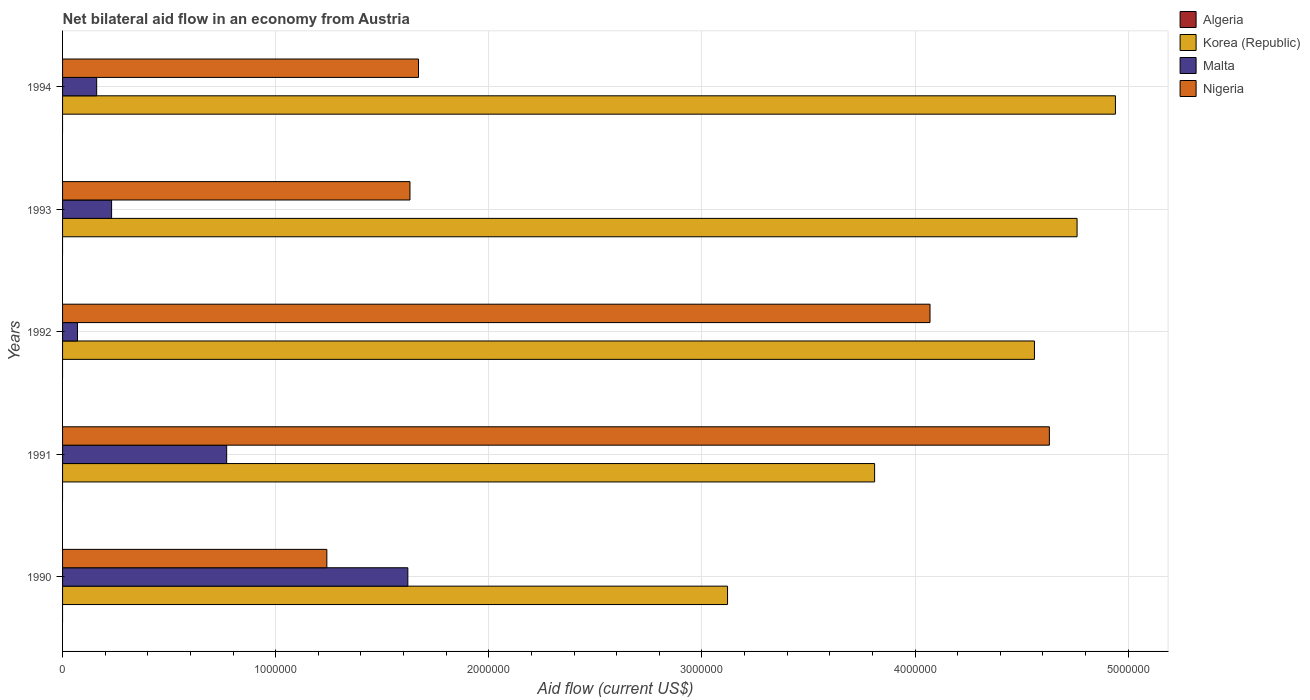Are the number of bars per tick equal to the number of legend labels?
Your answer should be compact. No. Are the number of bars on each tick of the Y-axis equal?
Provide a short and direct response. Yes. How many bars are there on the 5th tick from the bottom?
Make the answer very short. 3. What is the net bilateral aid flow in Korea (Republic) in 1994?
Provide a short and direct response. 4.94e+06. Across all years, what is the maximum net bilateral aid flow in Nigeria?
Offer a terse response. 4.63e+06. Across all years, what is the minimum net bilateral aid flow in Algeria?
Offer a terse response. 0. In which year was the net bilateral aid flow in Korea (Republic) maximum?
Your answer should be compact. 1994. What is the total net bilateral aid flow in Nigeria in the graph?
Make the answer very short. 1.32e+07. What is the difference between the net bilateral aid flow in Nigeria in 1990 and that in 1992?
Provide a short and direct response. -2.83e+06. What is the difference between the net bilateral aid flow in Nigeria in 1994 and the net bilateral aid flow in Malta in 1992?
Your answer should be very brief. 1.60e+06. What is the average net bilateral aid flow in Nigeria per year?
Your answer should be very brief. 2.65e+06. In the year 1993, what is the difference between the net bilateral aid flow in Nigeria and net bilateral aid flow in Malta?
Offer a terse response. 1.40e+06. In how many years, is the net bilateral aid flow in Nigeria greater than 3600000 US$?
Provide a short and direct response. 2. What is the ratio of the net bilateral aid flow in Malta in 1992 to that in 1993?
Offer a very short reply. 0.3. Is the net bilateral aid flow in Korea (Republic) in 1990 less than that in 1992?
Ensure brevity in your answer.  Yes. Is the difference between the net bilateral aid flow in Nigeria in 1990 and 1993 greater than the difference between the net bilateral aid flow in Malta in 1990 and 1993?
Offer a terse response. No. What is the difference between the highest and the lowest net bilateral aid flow in Malta?
Keep it short and to the point. 1.55e+06. In how many years, is the net bilateral aid flow in Korea (Republic) greater than the average net bilateral aid flow in Korea (Republic) taken over all years?
Offer a very short reply. 3. Is the sum of the net bilateral aid flow in Malta in 1992 and 1993 greater than the maximum net bilateral aid flow in Korea (Republic) across all years?
Your response must be concise. No. Is it the case that in every year, the sum of the net bilateral aid flow in Malta and net bilateral aid flow in Nigeria is greater than the net bilateral aid flow in Korea (Republic)?
Keep it short and to the point. No. How many bars are there?
Provide a succinct answer. 15. Are all the bars in the graph horizontal?
Provide a succinct answer. Yes. How many legend labels are there?
Provide a short and direct response. 4. What is the title of the graph?
Provide a short and direct response. Net bilateral aid flow in an economy from Austria. What is the label or title of the Y-axis?
Provide a succinct answer. Years. What is the Aid flow (current US$) in Korea (Republic) in 1990?
Keep it short and to the point. 3.12e+06. What is the Aid flow (current US$) in Malta in 1990?
Make the answer very short. 1.62e+06. What is the Aid flow (current US$) of Nigeria in 1990?
Offer a very short reply. 1.24e+06. What is the Aid flow (current US$) of Korea (Republic) in 1991?
Ensure brevity in your answer.  3.81e+06. What is the Aid flow (current US$) of Malta in 1991?
Make the answer very short. 7.70e+05. What is the Aid flow (current US$) in Nigeria in 1991?
Provide a short and direct response. 4.63e+06. What is the Aid flow (current US$) of Korea (Republic) in 1992?
Your response must be concise. 4.56e+06. What is the Aid flow (current US$) in Malta in 1992?
Ensure brevity in your answer.  7.00e+04. What is the Aid flow (current US$) in Nigeria in 1992?
Your response must be concise. 4.07e+06. What is the Aid flow (current US$) in Algeria in 1993?
Your response must be concise. 0. What is the Aid flow (current US$) in Korea (Republic) in 1993?
Give a very brief answer. 4.76e+06. What is the Aid flow (current US$) in Malta in 1993?
Provide a succinct answer. 2.30e+05. What is the Aid flow (current US$) in Nigeria in 1993?
Your answer should be very brief. 1.63e+06. What is the Aid flow (current US$) in Algeria in 1994?
Ensure brevity in your answer.  0. What is the Aid flow (current US$) of Korea (Republic) in 1994?
Provide a succinct answer. 4.94e+06. What is the Aid flow (current US$) in Malta in 1994?
Provide a short and direct response. 1.60e+05. What is the Aid flow (current US$) in Nigeria in 1994?
Ensure brevity in your answer.  1.67e+06. Across all years, what is the maximum Aid flow (current US$) in Korea (Republic)?
Make the answer very short. 4.94e+06. Across all years, what is the maximum Aid flow (current US$) in Malta?
Ensure brevity in your answer.  1.62e+06. Across all years, what is the maximum Aid flow (current US$) in Nigeria?
Make the answer very short. 4.63e+06. Across all years, what is the minimum Aid flow (current US$) in Korea (Republic)?
Your answer should be very brief. 3.12e+06. Across all years, what is the minimum Aid flow (current US$) in Malta?
Keep it short and to the point. 7.00e+04. Across all years, what is the minimum Aid flow (current US$) of Nigeria?
Keep it short and to the point. 1.24e+06. What is the total Aid flow (current US$) in Korea (Republic) in the graph?
Keep it short and to the point. 2.12e+07. What is the total Aid flow (current US$) of Malta in the graph?
Ensure brevity in your answer.  2.85e+06. What is the total Aid flow (current US$) in Nigeria in the graph?
Provide a short and direct response. 1.32e+07. What is the difference between the Aid flow (current US$) of Korea (Republic) in 1990 and that in 1991?
Offer a terse response. -6.90e+05. What is the difference between the Aid flow (current US$) of Malta in 1990 and that in 1991?
Offer a terse response. 8.50e+05. What is the difference between the Aid flow (current US$) in Nigeria in 1990 and that in 1991?
Your answer should be compact. -3.39e+06. What is the difference between the Aid flow (current US$) in Korea (Republic) in 1990 and that in 1992?
Give a very brief answer. -1.44e+06. What is the difference between the Aid flow (current US$) in Malta in 1990 and that in 1992?
Give a very brief answer. 1.55e+06. What is the difference between the Aid flow (current US$) of Nigeria in 1990 and that in 1992?
Give a very brief answer. -2.83e+06. What is the difference between the Aid flow (current US$) in Korea (Republic) in 1990 and that in 1993?
Ensure brevity in your answer.  -1.64e+06. What is the difference between the Aid flow (current US$) in Malta in 1990 and that in 1993?
Your answer should be very brief. 1.39e+06. What is the difference between the Aid flow (current US$) of Nigeria in 1990 and that in 1993?
Provide a succinct answer. -3.90e+05. What is the difference between the Aid flow (current US$) in Korea (Republic) in 1990 and that in 1994?
Offer a very short reply. -1.82e+06. What is the difference between the Aid flow (current US$) of Malta in 1990 and that in 1994?
Ensure brevity in your answer.  1.46e+06. What is the difference between the Aid flow (current US$) in Nigeria in 1990 and that in 1994?
Your answer should be very brief. -4.30e+05. What is the difference between the Aid flow (current US$) of Korea (Republic) in 1991 and that in 1992?
Offer a terse response. -7.50e+05. What is the difference between the Aid flow (current US$) in Malta in 1991 and that in 1992?
Ensure brevity in your answer.  7.00e+05. What is the difference between the Aid flow (current US$) in Nigeria in 1991 and that in 1992?
Keep it short and to the point. 5.60e+05. What is the difference between the Aid flow (current US$) of Korea (Republic) in 1991 and that in 1993?
Offer a very short reply. -9.50e+05. What is the difference between the Aid flow (current US$) in Malta in 1991 and that in 1993?
Provide a succinct answer. 5.40e+05. What is the difference between the Aid flow (current US$) of Nigeria in 1991 and that in 1993?
Ensure brevity in your answer.  3.00e+06. What is the difference between the Aid flow (current US$) of Korea (Republic) in 1991 and that in 1994?
Your answer should be compact. -1.13e+06. What is the difference between the Aid flow (current US$) in Malta in 1991 and that in 1994?
Provide a short and direct response. 6.10e+05. What is the difference between the Aid flow (current US$) in Nigeria in 1991 and that in 1994?
Your answer should be very brief. 2.96e+06. What is the difference between the Aid flow (current US$) in Nigeria in 1992 and that in 1993?
Provide a succinct answer. 2.44e+06. What is the difference between the Aid flow (current US$) in Korea (Republic) in 1992 and that in 1994?
Ensure brevity in your answer.  -3.80e+05. What is the difference between the Aid flow (current US$) of Nigeria in 1992 and that in 1994?
Your response must be concise. 2.40e+06. What is the difference between the Aid flow (current US$) in Malta in 1993 and that in 1994?
Keep it short and to the point. 7.00e+04. What is the difference between the Aid flow (current US$) of Nigeria in 1993 and that in 1994?
Provide a succinct answer. -4.00e+04. What is the difference between the Aid flow (current US$) in Korea (Republic) in 1990 and the Aid flow (current US$) in Malta in 1991?
Provide a succinct answer. 2.35e+06. What is the difference between the Aid flow (current US$) of Korea (Republic) in 1990 and the Aid flow (current US$) of Nigeria in 1991?
Keep it short and to the point. -1.51e+06. What is the difference between the Aid flow (current US$) in Malta in 1990 and the Aid flow (current US$) in Nigeria in 1991?
Ensure brevity in your answer.  -3.01e+06. What is the difference between the Aid flow (current US$) of Korea (Republic) in 1990 and the Aid flow (current US$) of Malta in 1992?
Give a very brief answer. 3.05e+06. What is the difference between the Aid flow (current US$) of Korea (Republic) in 1990 and the Aid flow (current US$) of Nigeria in 1992?
Provide a short and direct response. -9.50e+05. What is the difference between the Aid flow (current US$) of Malta in 1990 and the Aid flow (current US$) of Nigeria in 1992?
Provide a succinct answer. -2.45e+06. What is the difference between the Aid flow (current US$) of Korea (Republic) in 1990 and the Aid flow (current US$) of Malta in 1993?
Keep it short and to the point. 2.89e+06. What is the difference between the Aid flow (current US$) in Korea (Republic) in 1990 and the Aid flow (current US$) in Nigeria in 1993?
Your response must be concise. 1.49e+06. What is the difference between the Aid flow (current US$) of Malta in 1990 and the Aid flow (current US$) of Nigeria in 1993?
Offer a terse response. -10000. What is the difference between the Aid flow (current US$) of Korea (Republic) in 1990 and the Aid flow (current US$) of Malta in 1994?
Give a very brief answer. 2.96e+06. What is the difference between the Aid flow (current US$) of Korea (Republic) in 1990 and the Aid flow (current US$) of Nigeria in 1994?
Your response must be concise. 1.45e+06. What is the difference between the Aid flow (current US$) in Korea (Republic) in 1991 and the Aid flow (current US$) in Malta in 1992?
Make the answer very short. 3.74e+06. What is the difference between the Aid flow (current US$) of Malta in 1991 and the Aid flow (current US$) of Nigeria in 1992?
Your answer should be compact. -3.30e+06. What is the difference between the Aid flow (current US$) of Korea (Republic) in 1991 and the Aid flow (current US$) of Malta in 1993?
Provide a short and direct response. 3.58e+06. What is the difference between the Aid flow (current US$) of Korea (Republic) in 1991 and the Aid flow (current US$) of Nigeria in 1993?
Your response must be concise. 2.18e+06. What is the difference between the Aid flow (current US$) of Malta in 1991 and the Aid flow (current US$) of Nigeria in 1993?
Your answer should be compact. -8.60e+05. What is the difference between the Aid flow (current US$) in Korea (Republic) in 1991 and the Aid flow (current US$) in Malta in 1994?
Your answer should be very brief. 3.65e+06. What is the difference between the Aid flow (current US$) of Korea (Republic) in 1991 and the Aid flow (current US$) of Nigeria in 1994?
Give a very brief answer. 2.14e+06. What is the difference between the Aid flow (current US$) in Malta in 1991 and the Aid flow (current US$) in Nigeria in 1994?
Offer a terse response. -9.00e+05. What is the difference between the Aid flow (current US$) in Korea (Republic) in 1992 and the Aid flow (current US$) in Malta in 1993?
Keep it short and to the point. 4.33e+06. What is the difference between the Aid flow (current US$) in Korea (Republic) in 1992 and the Aid flow (current US$) in Nigeria in 1993?
Offer a very short reply. 2.93e+06. What is the difference between the Aid flow (current US$) in Malta in 1992 and the Aid flow (current US$) in Nigeria in 1993?
Keep it short and to the point. -1.56e+06. What is the difference between the Aid flow (current US$) of Korea (Republic) in 1992 and the Aid flow (current US$) of Malta in 1994?
Give a very brief answer. 4.40e+06. What is the difference between the Aid flow (current US$) in Korea (Republic) in 1992 and the Aid flow (current US$) in Nigeria in 1994?
Ensure brevity in your answer.  2.89e+06. What is the difference between the Aid flow (current US$) in Malta in 1992 and the Aid flow (current US$) in Nigeria in 1994?
Ensure brevity in your answer.  -1.60e+06. What is the difference between the Aid flow (current US$) of Korea (Republic) in 1993 and the Aid flow (current US$) of Malta in 1994?
Give a very brief answer. 4.60e+06. What is the difference between the Aid flow (current US$) of Korea (Republic) in 1993 and the Aid flow (current US$) of Nigeria in 1994?
Offer a very short reply. 3.09e+06. What is the difference between the Aid flow (current US$) in Malta in 1993 and the Aid flow (current US$) in Nigeria in 1994?
Offer a terse response. -1.44e+06. What is the average Aid flow (current US$) in Algeria per year?
Keep it short and to the point. 0. What is the average Aid flow (current US$) in Korea (Republic) per year?
Your answer should be very brief. 4.24e+06. What is the average Aid flow (current US$) in Malta per year?
Provide a short and direct response. 5.70e+05. What is the average Aid flow (current US$) in Nigeria per year?
Offer a very short reply. 2.65e+06. In the year 1990, what is the difference between the Aid flow (current US$) of Korea (Republic) and Aid flow (current US$) of Malta?
Offer a very short reply. 1.50e+06. In the year 1990, what is the difference between the Aid flow (current US$) in Korea (Republic) and Aid flow (current US$) in Nigeria?
Offer a very short reply. 1.88e+06. In the year 1991, what is the difference between the Aid flow (current US$) of Korea (Republic) and Aid flow (current US$) of Malta?
Ensure brevity in your answer.  3.04e+06. In the year 1991, what is the difference between the Aid flow (current US$) in Korea (Republic) and Aid flow (current US$) in Nigeria?
Your answer should be very brief. -8.20e+05. In the year 1991, what is the difference between the Aid flow (current US$) in Malta and Aid flow (current US$) in Nigeria?
Offer a terse response. -3.86e+06. In the year 1992, what is the difference between the Aid flow (current US$) in Korea (Republic) and Aid flow (current US$) in Malta?
Give a very brief answer. 4.49e+06. In the year 1992, what is the difference between the Aid flow (current US$) of Korea (Republic) and Aid flow (current US$) of Nigeria?
Offer a terse response. 4.90e+05. In the year 1993, what is the difference between the Aid flow (current US$) in Korea (Republic) and Aid flow (current US$) in Malta?
Give a very brief answer. 4.53e+06. In the year 1993, what is the difference between the Aid flow (current US$) in Korea (Republic) and Aid flow (current US$) in Nigeria?
Your response must be concise. 3.13e+06. In the year 1993, what is the difference between the Aid flow (current US$) in Malta and Aid flow (current US$) in Nigeria?
Your answer should be very brief. -1.40e+06. In the year 1994, what is the difference between the Aid flow (current US$) of Korea (Republic) and Aid flow (current US$) of Malta?
Offer a very short reply. 4.78e+06. In the year 1994, what is the difference between the Aid flow (current US$) of Korea (Republic) and Aid flow (current US$) of Nigeria?
Give a very brief answer. 3.27e+06. In the year 1994, what is the difference between the Aid flow (current US$) in Malta and Aid flow (current US$) in Nigeria?
Offer a very short reply. -1.51e+06. What is the ratio of the Aid flow (current US$) in Korea (Republic) in 1990 to that in 1991?
Provide a succinct answer. 0.82. What is the ratio of the Aid flow (current US$) in Malta in 1990 to that in 1991?
Provide a succinct answer. 2.1. What is the ratio of the Aid flow (current US$) of Nigeria in 1990 to that in 1991?
Your answer should be compact. 0.27. What is the ratio of the Aid flow (current US$) in Korea (Republic) in 1990 to that in 1992?
Your answer should be compact. 0.68. What is the ratio of the Aid flow (current US$) of Malta in 1990 to that in 1992?
Provide a succinct answer. 23.14. What is the ratio of the Aid flow (current US$) in Nigeria in 1990 to that in 1992?
Provide a succinct answer. 0.3. What is the ratio of the Aid flow (current US$) in Korea (Republic) in 1990 to that in 1993?
Your answer should be compact. 0.66. What is the ratio of the Aid flow (current US$) in Malta in 1990 to that in 1993?
Your response must be concise. 7.04. What is the ratio of the Aid flow (current US$) in Nigeria in 1990 to that in 1993?
Ensure brevity in your answer.  0.76. What is the ratio of the Aid flow (current US$) in Korea (Republic) in 1990 to that in 1994?
Make the answer very short. 0.63. What is the ratio of the Aid flow (current US$) of Malta in 1990 to that in 1994?
Your response must be concise. 10.12. What is the ratio of the Aid flow (current US$) in Nigeria in 1990 to that in 1994?
Ensure brevity in your answer.  0.74. What is the ratio of the Aid flow (current US$) in Korea (Republic) in 1991 to that in 1992?
Your response must be concise. 0.84. What is the ratio of the Aid flow (current US$) of Nigeria in 1991 to that in 1992?
Offer a terse response. 1.14. What is the ratio of the Aid flow (current US$) of Korea (Republic) in 1991 to that in 1993?
Provide a succinct answer. 0.8. What is the ratio of the Aid flow (current US$) of Malta in 1991 to that in 1993?
Give a very brief answer. 3.35. What is the ratio of the Aid flow (current US$) in Nigeria in 1991 to that in 1993?
Make the answer very short. 2.84. What is the ratio of the Aid flow (current US$) of Korea (Republic) in 1991 to that in 1994?
Give a very brief answer. 0.77. What is the ratio of the Aid flow (current US$) of Malta in 1991 to that in 1994?
Your response must be concise. 4.81. What is the ratio of the Aid flow (current US$) in Nigeria in 1991 to that in 1994?
Your answer should be very brief. 2.77. What is the ratio of the Aid flow (current US$) in Korea (Republic) in 1992 to that in 1993?
Offer a very short reply. 0.96. What is the ratio of the Aid flow (current US$) of Malta in 1992 to that in 1993?
Keep it short and to the point. 0.3. What is the ratio of the Aid flow (current US$) in Nigeria in 1992 to that in 1993?
Provide a succinct answer. 2.5. What is the ratio of the Aid flow (current US$) of Malta in 1992 to that in 1994?
Offer a terse response. 0.44. What is the ratio of the Aid flow (current US$) of Nigeria in 1992 to that in 1994?
Provide a short and direct response. 2.44. What is the ratio of the Aid flow (current US$) of Korea (Republic) in 1993 to that in 1994?
Keep it short and to the point. 0.96. What is the ratio of the Aid flow (current US$) of Malta in 1993 to that in 1994?
Offer a very short reply. 1.44. What is the ratio of the Aid flow (current US$) of Nigeria in 1993 to that in 1994?
Give a very brief answer. 0.98. What is the difference between the highest and the second highest Aid flow (current US$) in Korea (Republic)?
Provide a short and direct response. 1.80e+05. What is the difference between the highest and the second highest Aid flow (current US$) in Malta?
Keep it short and to the point. 8.50e+05. What is the difference between the highest and the second highest Aid flow (current US$) in Nigeria?
Your answer should be compact. 5.60e+05. What is the difference between the highest and the lowest Aid flow (current US$) in Korea (Republic)?
Provide a short and direct response. 1.82e+06. What is the difference between the highest and the lowest Aid flow (current US$) of Malta?
Your response must be concise. 1.55e+06. What is the difference between the highest and the lowest Aid flow (current US$) in Nigeria?
Ensure brevity in your answer.  3.39e+06. 